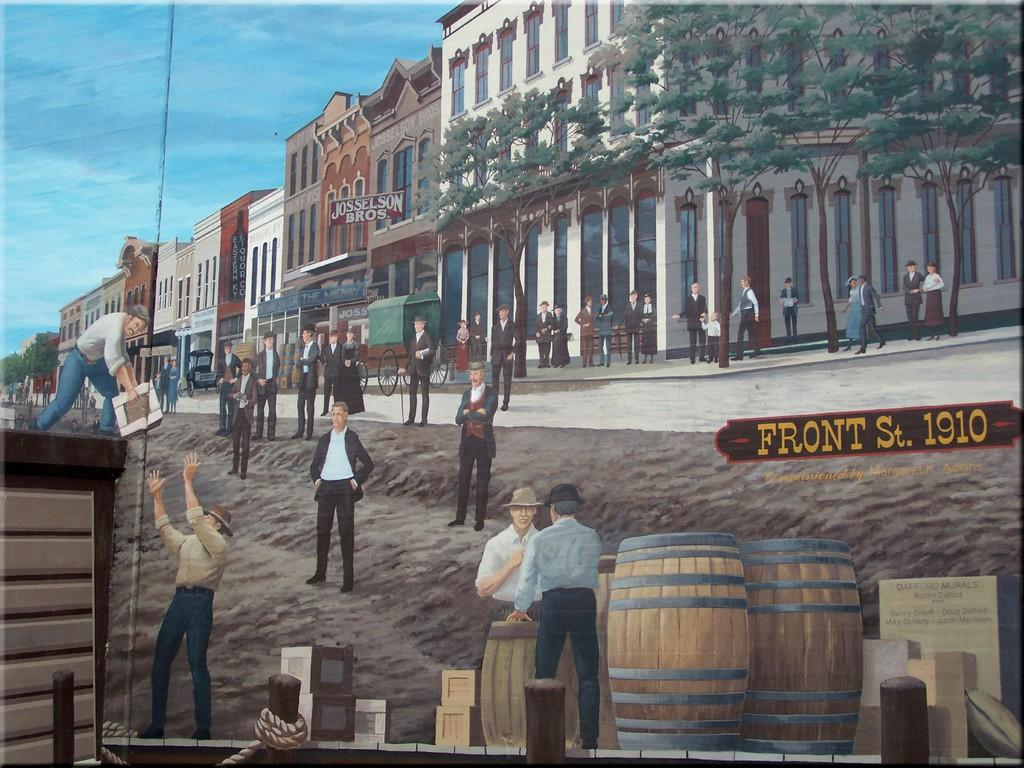<image>
Present a compact description of the photo's key features. An artist's drawing of Front Street as it appeared in 1910. 